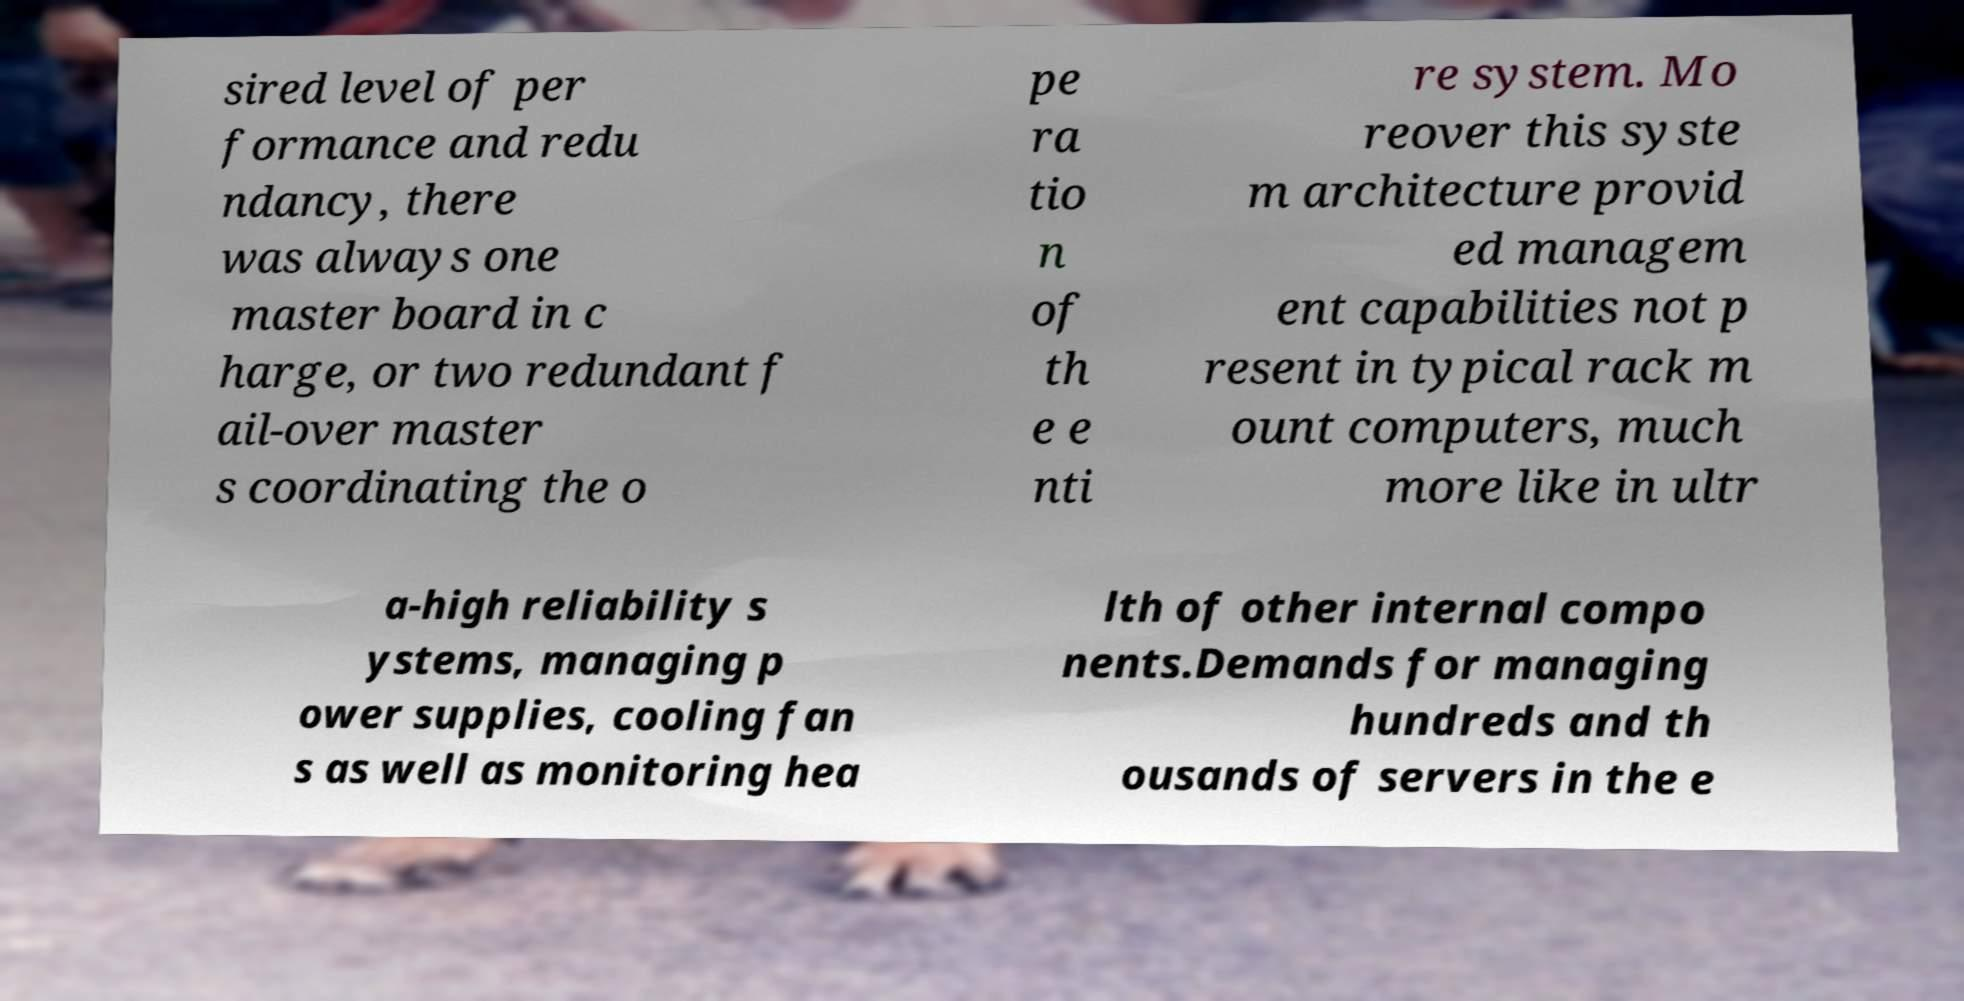What messages or text are displayed in this image? I need them in a readable, typed format. sired level of per formance and redu ndancy, there was always one master board in c harge, or two redundant f ail-over master s coordinating the o pe ra tio n of th e e nti re system. Mo reover this syste m architecture provid ed managem ent capabilities not p resent in typical rack m ount computers, much more like in ultr a-high reliability s ystems, managing p ower supplies, cooling fan s as well as monitoring hea lth of other internal compo nents.Demands for managing hundreds and th ousands of servers in the e 